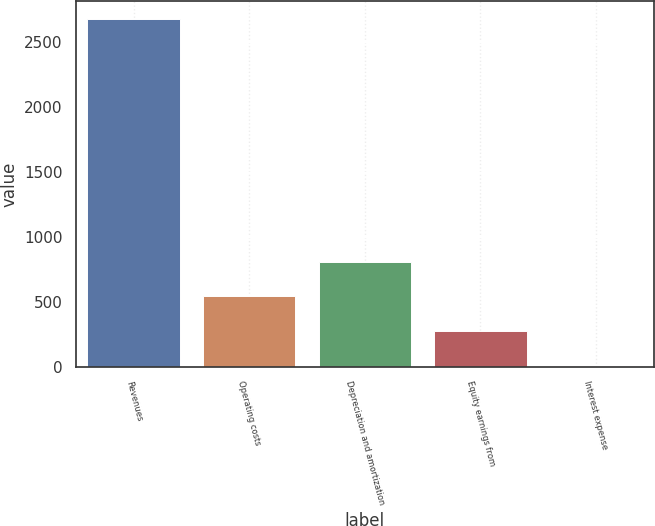Convert chart. <chart><loc_0><loc_0><loc_500><loc_500><bar_chart><fcel>Revenues<fcel>Operating costs<fcel>Depreciation and amortization<fcel>Equity earnings from<fcel>Interest expense<nl><fcel>2680<fcel>542.32<fcel>809.53<fcel>275.11<fcel>7.9<nl></chart> 